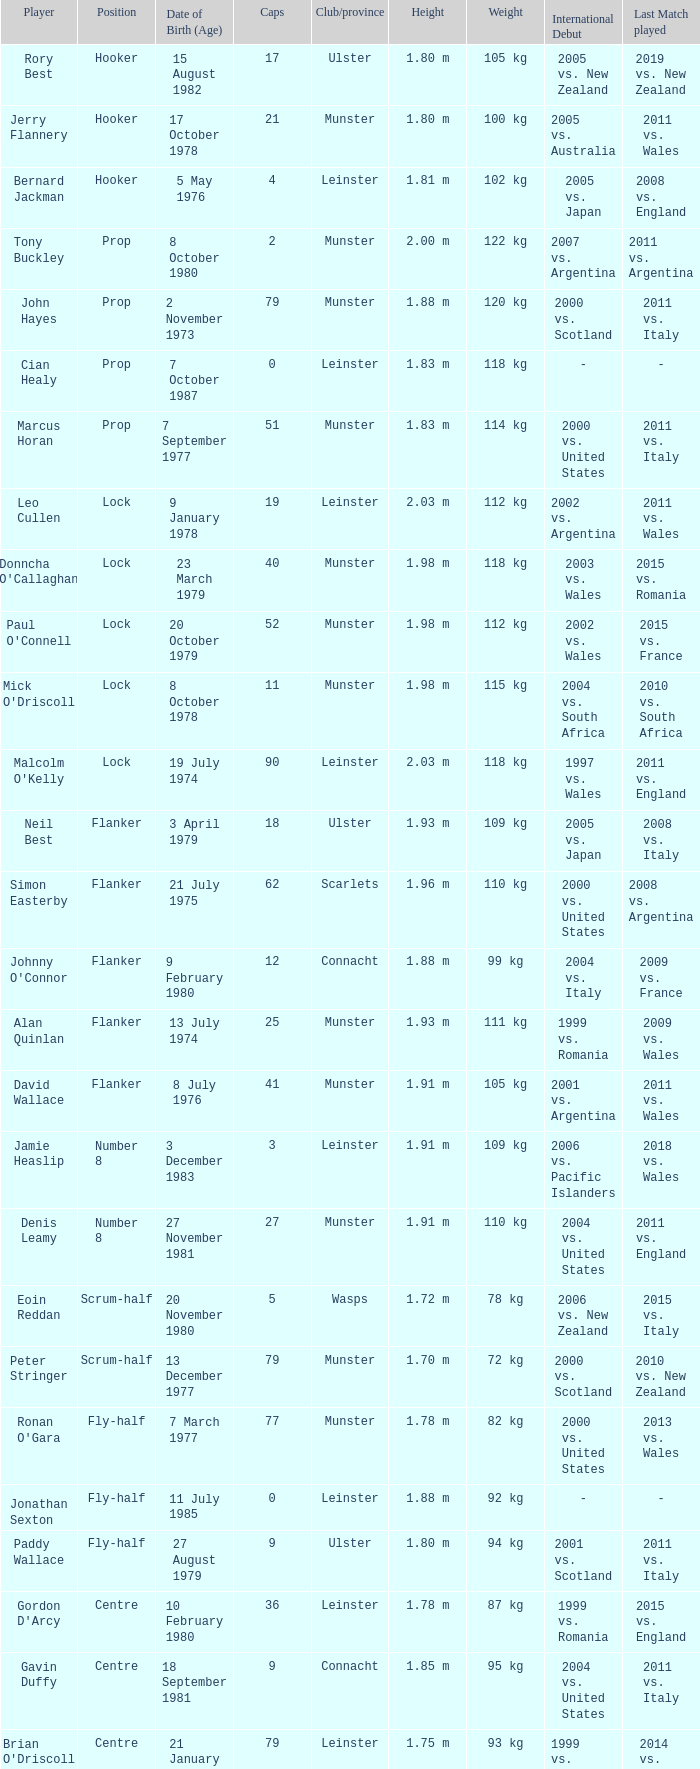What is the total of Caps when player born 13 December 1977? 79.0. 